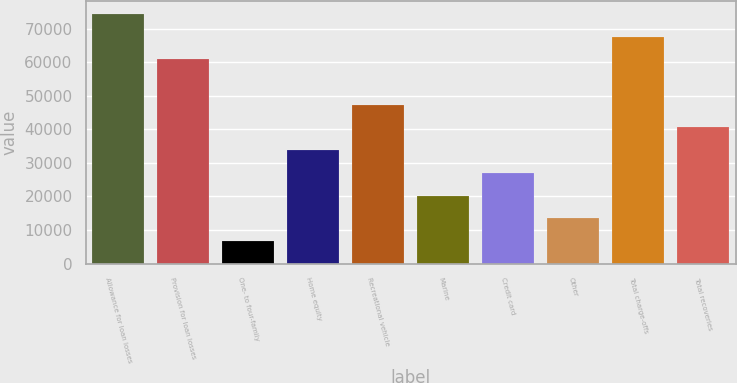Convert chart. <chart><loc_0><loc_0><loc_500><loc_500><bar_chart><fcel>Allowance for loan losses<fcel>Provision for loan losses<fcel>One- to four-family<fcel>Home equity<fcel>Recreational vehicle<fcel>Marine<fcel>Credit card<fcel>Other<fcel>Total charge-offs<fcel>Total recoveries<nl><fcel>74390.8<fcel>60865.2<fcel>6762.96<fcel>33814.1<fcel>47339.6<fcel>20288.5<fcel>27051.3<fcel>13525.7<fcel>67628<fcel>40576.9<nl></chart> 